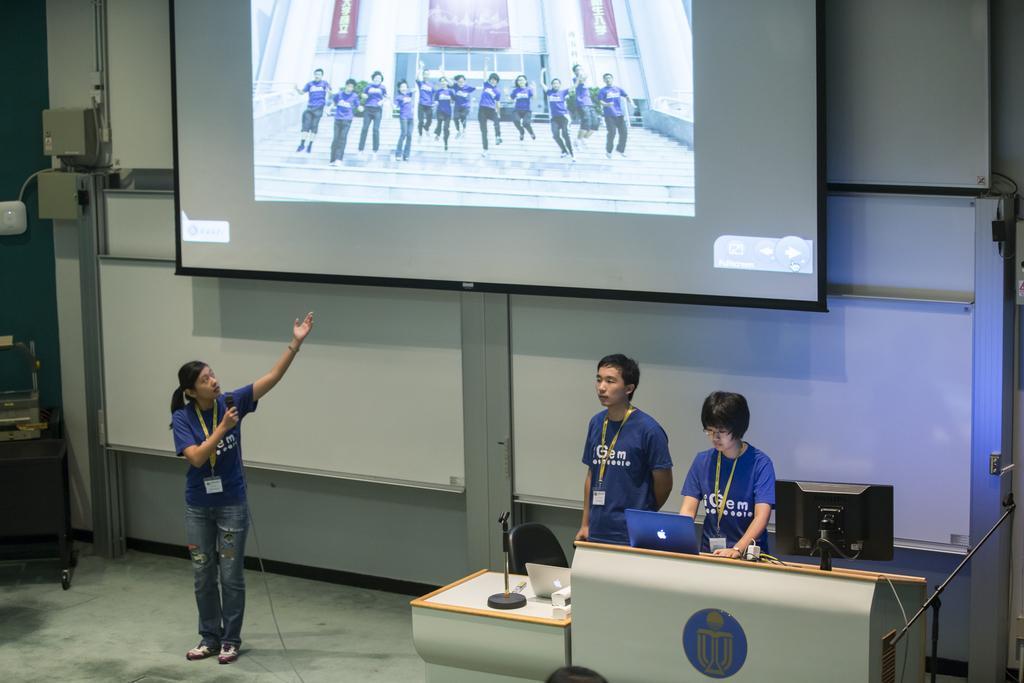How would you summarize this image in a sentence or two? This is an inside view. At the top there is a screen attached to the wall. On the left side there is a girl wearing t-shirt, jeans, standing, holding a mike in the hand and looking at the screen. On the right side there are two people standing in front of the podium. One person is looking into the laptop and also there is a monitor. On the left side there is a table on which few objects are placed. 